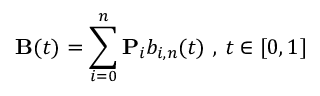Convert formula to latex. <formula><loc_0><loc_0><loc_500><loc_500>B ( t ) = \sum _ { i = 0 } ^ { n } P _ { i } b _ { i , n } ( t ) { , } t \in [ 0 , 1 ]</formula> 